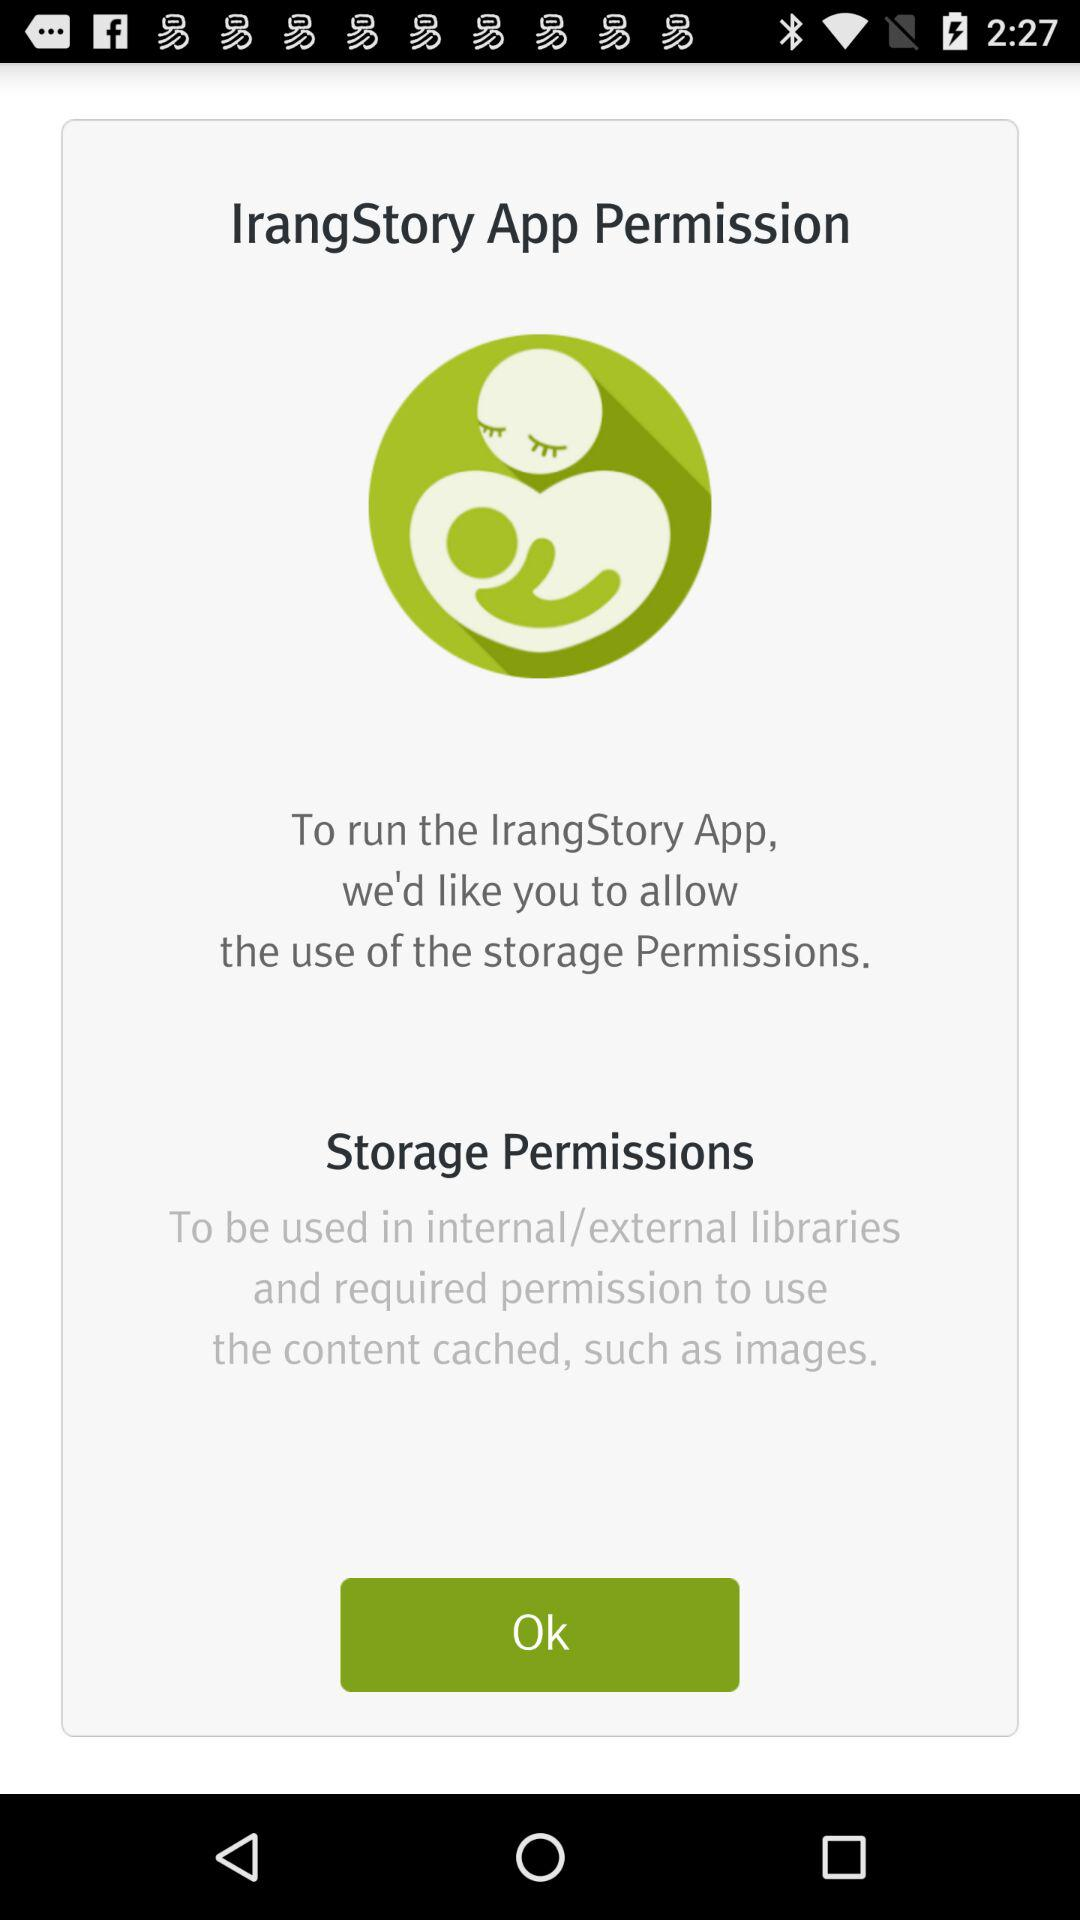What is the name of application? The name of the application is "IrangStory". 